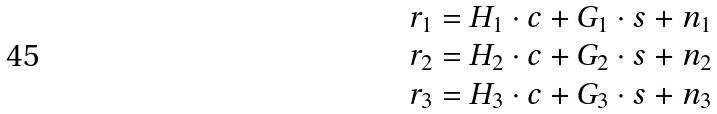Convert formula to latex. <formula><loc_0><loc_0><loc_500><loc_500>\begin{array} { l } { r } _ { 1 } = { H } _ { 1 } \cdot { c } + { G } _ { 1 } \cdot { s } + { n } _ { 1 } \\ { r } _ { 2 } = { H } _ { 2 } \cdot { c } + { G } _ { 2 } \cdot { s } + { n } _ { 2 } \\ { r } _ { 3 } = { H } _ { 3 } \cdot { c } + { G } _ { 3 } \cdot { s } + { n } _ { 3 } \\ \end{array}</formula> 